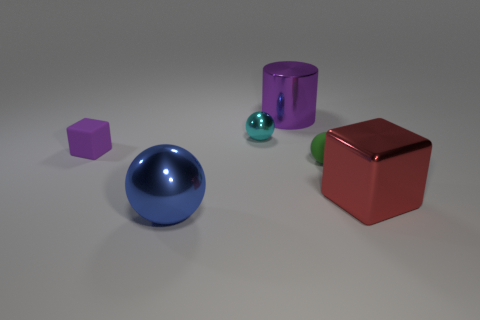Subtract all purple cubes. How many cubes are left? 1 Subtract all tiny balls. How many balls are left? 1 Add 2 cylinders. How many objects exist? 8 Subtract 2 balls. How many balls are left? 1 Subtract all cyan balls. Subtract all large green shiny cylinders. How many objects are left? 5 Add 4 small spheres. How many small spheres are left? 6 Add 5 tiny gray rubber spheres. How many tiny gray rubber spheres exist? 5 Subtract 0 blue cylinders. How many objects are left? 6 Subtract all cylinders. How many objects are left? 5 Subtract all gray balls. Subtract all red cylinders. How many balls are left? 3 